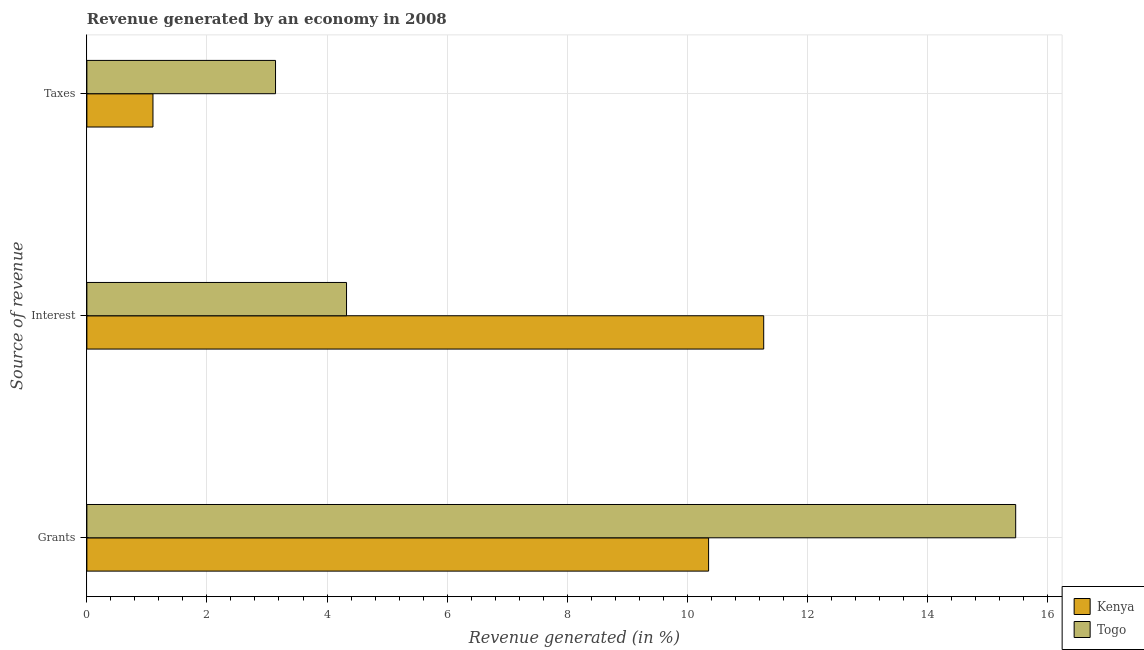Are the number of bars per tick equal to the number of legend labels?
Your response must be concise. Yes. How many bars are there on the 3rd tick from the bottom?
Give a very brief answer. 2. What is the label of the 1st group of bars from the top?
Give a very brief answer. Taxes. What is the percentage of revenue generated by grants in Togo?
Your answer should be very brief. 15.47. Across all countries, what is the maximum percentage of revenue generated by taxes?
Ensure brevity in your answer.  3.14. Across all countries, what is the minimum percentage of revenue generated by grants?
Provide a short and direct response. 10.36. In which country was the percentage of revenue generated by interest maximum?
Provide a succinct answer. Kenya. In which country was the percentage of revenue generated by interest minimum?
Offer a very short reply. Togo. What is the total percentage of revenue generated by interest in the graph?
Keep it short and to the point. 15.6. What is the difference between the percentage of revenue generated by taxes in Togo and that in Kenya?
Provide a succinct answer. 2.04. What is the difference between the percentage of revenue generated by taxes in Kenya and the percentage of revenue generated by grants in Togo?
Your answer should be compact. -14.37. What is the average percentage of revenue generated by interest per country?
Ensure brevity in your answer.  7.8. What is the difference between the percentage of revenue generated by interest and percentage of revenue generated by taxes in Kenya?
Your answer should be compact. 10.17. What is the ratio of the percentage of revenue generated by grants in Kenya to that in Togo?
Provide a short and direct response. 0.67. What is the difference between the highest and the second highest percentage of revenue generated by interest?
Your response must be concise. 6.95. What is the difference between the highest and the lowest percentage of revenue generated by interest?
Your answer should be compact. 6.95. In how many countries, is the percentage of revenue generated by taxes greater than the average percentage of revenue generated by taxes taken over all countries?
Offer a terse response. 1. Is the sum of the percentage of revenue generated by taxes in Togo and Kenya greater than the maximum percentage of revenue generated by grants across all countries?
Provide a succinct answer. No. What does the 1st bar from the top in Grants represents?
Keep it short and to the point. Togo. What does the 2nd bar from the bottom in Taxes represents?
Give a very brief answer. Togo. Are all the bars in the graph horizontal?
Make the answer very short. Yes. Does the graph contain any zero values?
Give a very brief answer. No. Where does the legend appear in the graph?
Your answer should be compact. Bottom right. What is the title of the graph?
Ensure brevity in your answer.  Revenue generated by an economy in 2008. What is the label or title of the X-axis?
Your answer should be very brief. Revenue generated (in %). What is the label or title of the Y-axis?
Your answer should be compact. Source of revenue. What is the Revenue generated (in %) of Kenya in Grants?
Your response must be concise. 10.36. What is the Revenue generated (in %) in Togo in Grants?
Give a very brief answer. 15.47. What is the Revenue generated (in %) of Kenya in Interest?
Give a very brief answer. 11.27. What is the Revenue generated (in %) of Togo in Interest?
Ensure brevity in your answer.  4.33. What is the Revenue generated (in %) in Kenya in Taxes?
Offer a terse response. 1.1. What is the Revenue generated (in %) in Togo in Taxes?
Provide a succinct answer. 3.14. Across all Source of revenue, what is the maximum Revenue generated (in %) in Kenya?
Offer a very short reply. 11.27. Across all Source of revenue, what is the maximum Revenue generated (in %) in Togo?
Make the answer very short. 15.47. Across all Source of revenue, what is the minimum Revenue generated (in %) of Kenya?
Give a very brief answer. 1.1. Across all Source of revenue, what is the minimum Revenue generated (in %) of Togo?
Your answer should be very brief. 3.14. What is the total Revenue generated (in %) in Kenya in the graph?
Provide a short and direct response. 22.73. What is the total Revenue generated (in %) in Togo in the graph?
Your answer should be very brief. 22.94. What is the difference between the Revenue generated (in %) of Kenya in Grants and that in Interest?
Offer a terse response. -0.92. What is the difference between the Revenue generated (in %) in Togo in Grants and that in Interest?
Your response must be concise. 11.15. What is the difference between the Revenue generated (in %) of Kenya in Grants and that in Taxes?
Provide a succinct answer. 9.26. What is the difference between the Revenue generated (in %) of Togo in Grants and that in Taxes?
Your answer should be very brief. 12.33. What is the difference between the Revenue generated (in %) in Kenya in Interest and that in Taxes?
Provide a short and direct response. 10.17. What is the difference between the Revenue generated (in %) of Togo in Interest and that in Taxes?
Your response must be concise. 1.18. What is the difference between the Revenue generated (in %) of Kenya in Grants and the Revenue generated (in %) of Togo in Interest?
Your answer should be very brief. 6.03. What is the difference between the Revenue generated (in %) in Kenya in Grants and the Revenue generated (in %) in Togo in Taxes?
Give a very brief answer. 7.21. What is the difference between the Revenue generated (in %) in Kenya in Interest and the Revenue generated (in %) in Togo in Taxes?
Give a very brief answer. 8.13. What is the average Revenue generated (in %) of Kenya per Source of revenue?
Offer a very short reply. 7.58. What is the average Revenue generated (in %) in Togo per Source of revenue?
Ensure brevity in your answer.  7.65. What is the difference between the Revenue generated (in %) of Kenya and Revenue generated (in %) of Togo in Grants?
Your answer should be compact. -5.12. What is the difference between the Revenue generated (in %) of Kenya and Revenue generated (in %) of Togo in Interest?
Make the answer very short. 6.95. What is the difference between the Revenue generated (in %) in Kenya and Revenue generated (in %) in Togo in Taxes?
Ensure brevity in your answer.  -2.04. What is the ratio of the Revenue generated (in %) of Kenya in Grants to that in Interest?
Keep it short and to the point. 0.92. What is the ratio of the Revenue generated (in %) of Togo in Grants to that in Interest?
Your answer should be very brief. 3.58. What is the ratio of the Revenue generated (in %) in Kenya in Grants to that in Taxes?
Your response must be concise. 9.41. What is the ratio of the Revenue generated (in %) of Togo in Grants to that in Taxes?
Keep it short and to the point. 4.92. What is the ratio of the Revenue generated (in %) of Kenya in Interest to that in Taxes?
Your answer should be compact. 10.24. What is the ratio of the Revenue generated (in %) of Togo in Interest to that in Taxes?
Give a very brief answer. 1.38. What is the difference between the highest and the second highest Revenue generated (in %) of Kenya?
Offer a very short reply. 0.92. What is the difference between the highest and the second highest Revenue generated (in %) in Togo?
Your response must be concise. 11.15. What is the difference between the highest and the lowest Revenue generated (in %) in Kenya?
Provide a short and direct response. 10.17. What is the difference between the highest and the lowest Revenue generated (in %) in Togo?
Offer a terse response. 12.33. 